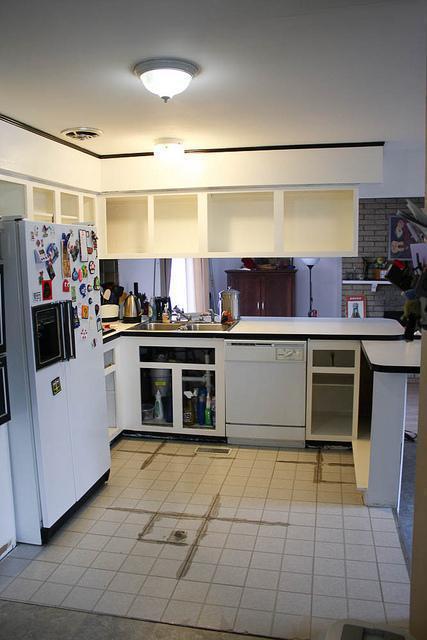What room is beyond the countertops?
Select the correct answer and articulate reasoning with the following format: 'Answer: answer
Rationale: rationale.'
Options: Living room, office, bathroom, bedroom. Answer: living room.
Rationale: The countertops are in the kitchen. the kitchen separates the kitchen and living room. 